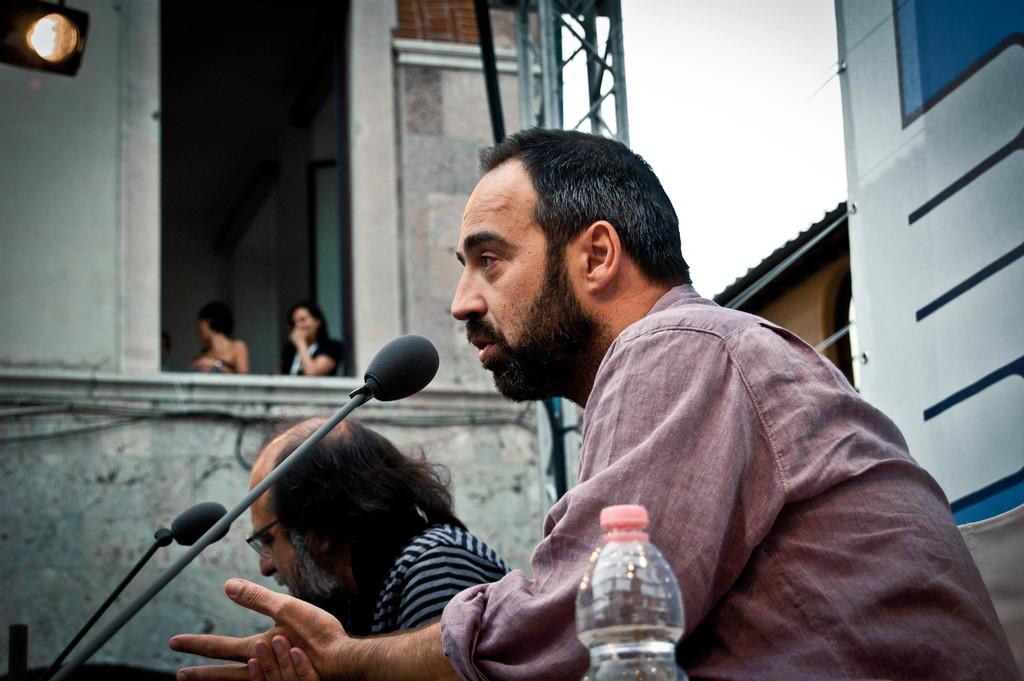What is the person in the image doing? The person is sitting in the image. What is the person sitting in front of? The person is sitting in front of a mic. What can be seen in the background of the image? There is a building in the image. Are there any other people visible in the image? Yes, women are standing near the building. What type of trousers is the grandfather wearing in the image? There is no grandfather present in the image, and therefore no one is wearing trousers. 